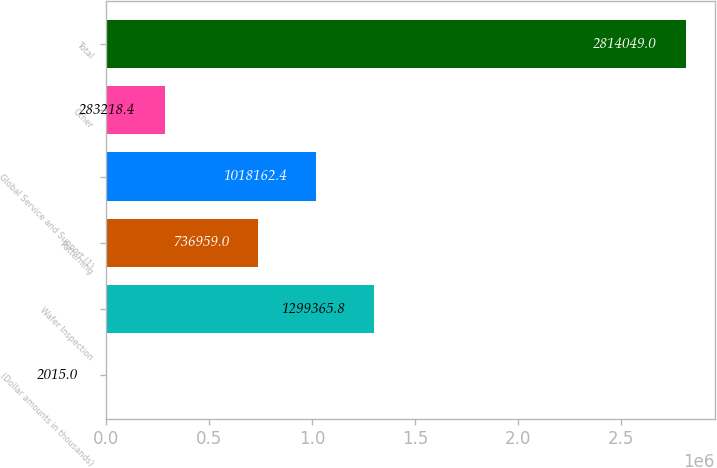Convert chart to OTSL. <chart><loc_0><loc_0><loc_500><loc_500><bar_chart><fcel>(Dollar amounts in thousands)<fcel>Wafer Inspection<fcel>Patterning<fcel>Global Service and Support (1)<fcel>Other<fcel>Total<nl><fcel>2015<fcel>1.29937e+06<fcel>736959<fcel>1.01816e+06<fcel>283218<fcel>2.81405e+06<nl></chart> 